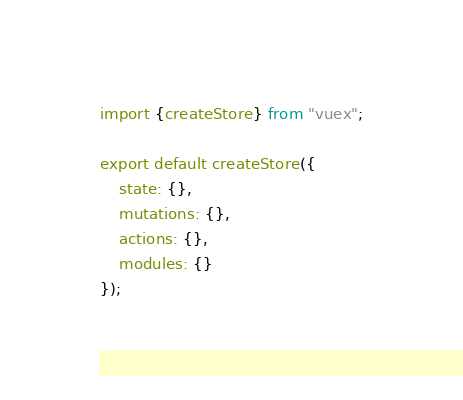<code> <loc_0><loc_0><loc_500><loc_500><_JavaScript_>import {createStore} from "vuex";

export default createStore({
	state: {},
	mutations: {},
	actions: {},
	modules: {}
});
</code> 